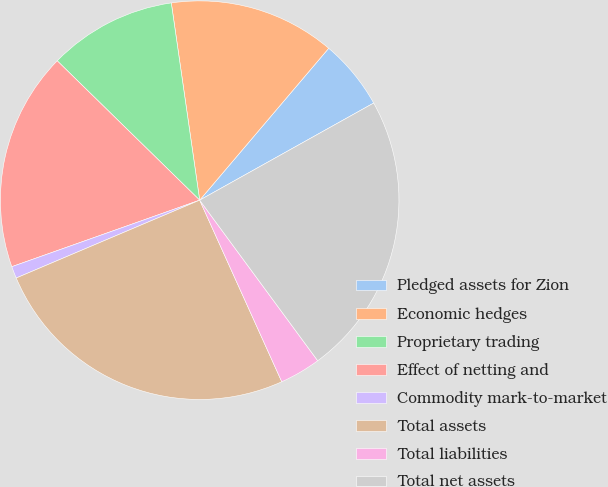<chart> <loc_0><loc_0><loc_500><loc_500><pie_chart><fcel>Pledged assets for Zion<fcel>Economic hedges<fcel>Proprietary trading<fcel>Effect of netting and<fcel>Commodity mark-to-market<fcel>Total assets<fcel>Total liabilities<fcel>Total net assets<nl><fcel>5.69%<fcel>13.48%<fcel>10.4%<fcel>17.74%<fcel>0.97%<fcel>25.37%<fcel>3.33%<fcel>23.01%<nl></chart> 